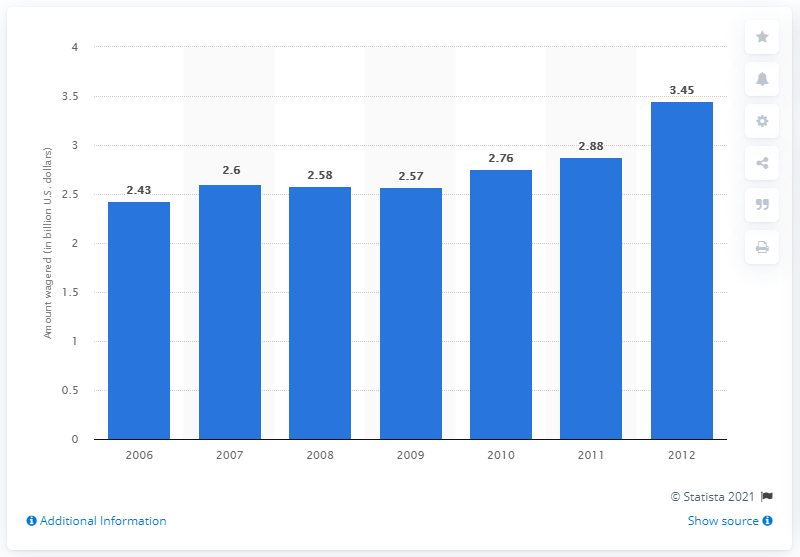Identify some key points in this picture. In 2007, the amount of money wagered on sporting events in Nevada was 2.58 billion dollars. 